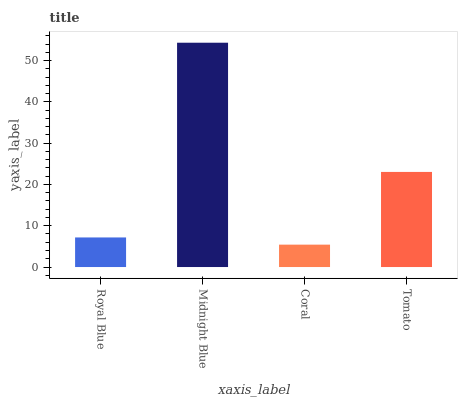Is Coral the minimum?
Answer yes or no. Yes. Is Midnight Blue the maximum?
Answer yes or no. Yes. Is Midnight Blue the minimum?
Answer yes or no. No. Is Coral the maximum?
Answer yes or no. No. Is Midnight Blue greater than Coral?
Answer yes or no. Yes. Is Coral less than Midnight Blue?
Answer yes or no. Yes. Is Coral greater than Midnight Blue?
Answer yes or no. No. Is Midnight Blue less than Coral?
Answer yes or no. No. Is Tomato the high median?
Answer yes or no. Yes. Is Royal Blue the low median?
Answer yes or no. Yes. Is Royal Blue the high median?
Answer yes or no. No. Is Coral the low median?
Answer yes or no. No. 